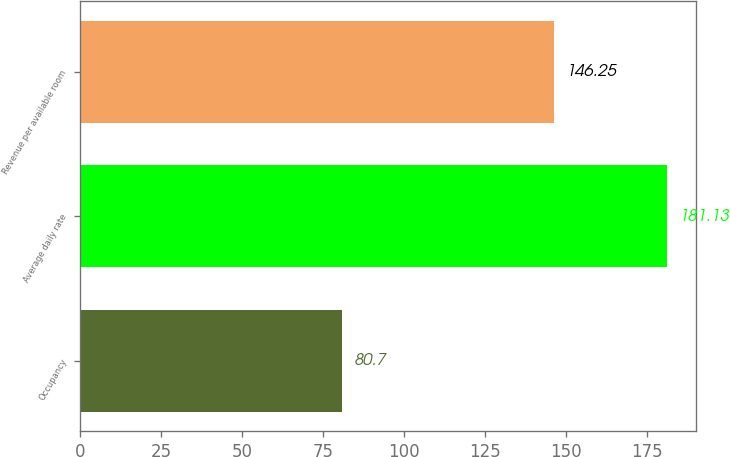Convert chart. <chart><loc_0><loc_0><loc_500><loc_500><bar_chart><fcel>Occupancy<fcel>Average daily rate<fcel>Revenue per available room<nl><fcel>80.7<fcel>181.13<fcel>146.25<nl></chart> 